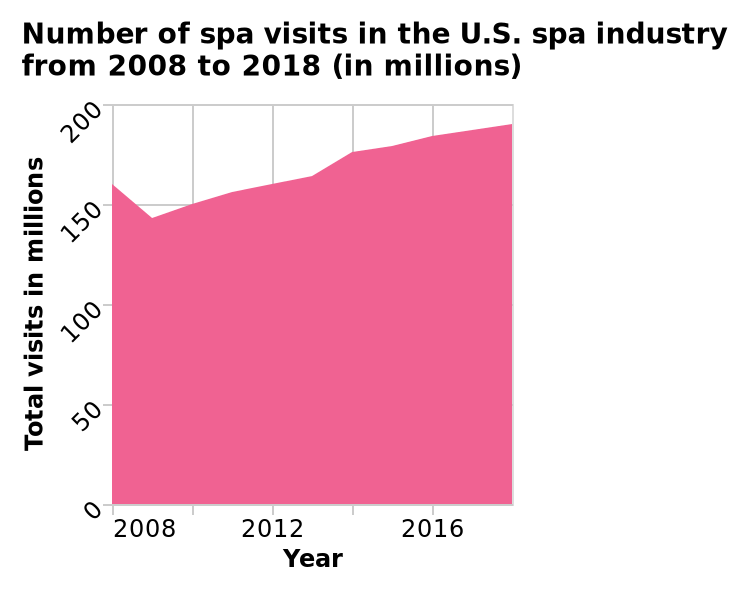<image>
What does the area diagram represent? The area diagram represents the number of spa visits in the U.S. spa industry over the years 2008 to 2018, measured in millions. What is the title of the area diagram?  The title of the area diagram is "Number of spa visits in the U.S. spa industry from 2008 to 2018 (in millions)". 